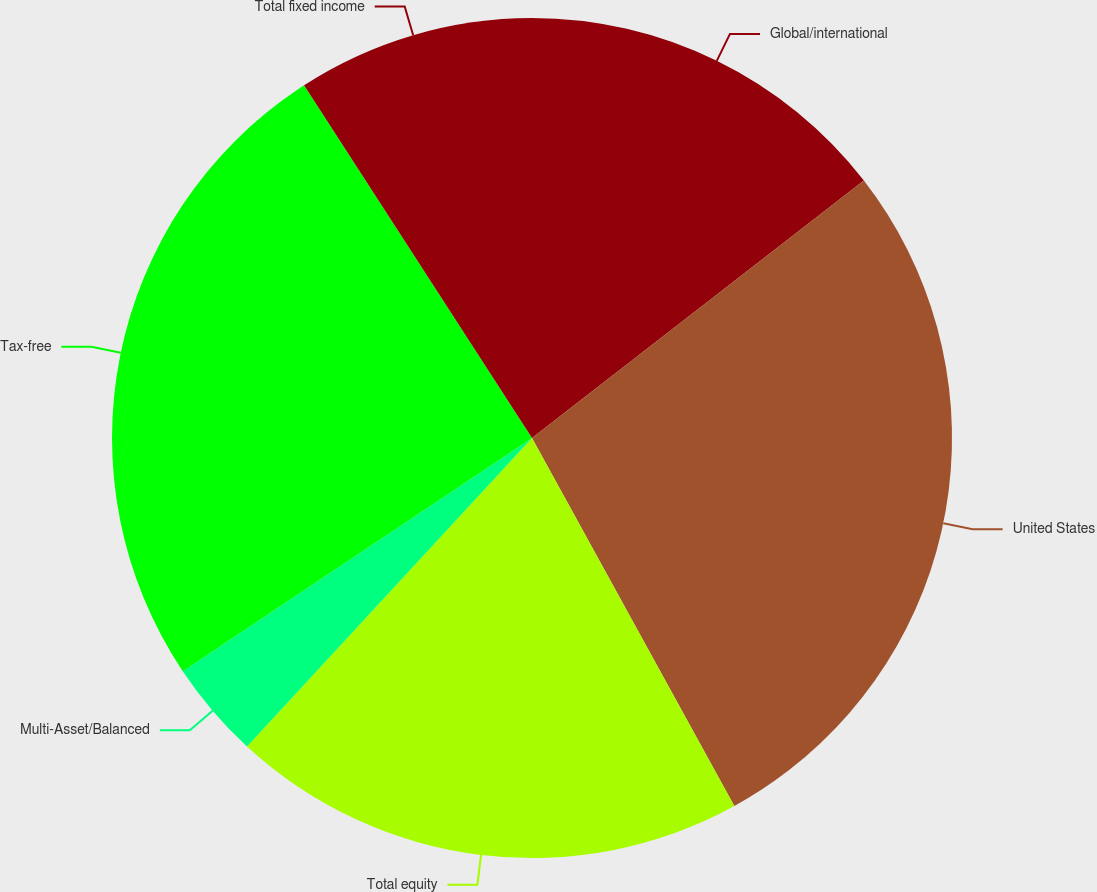Convert chart. <chart><loc_0><loc_0><loc_500><loc_500><pie_chart><fcel>Global/international<fcel>United States<fcel>Total equity<fcel>Multi-Asset/Balanced<fcel>Tax-free<fcel>Total fixed income<nl><fcel>14.5%<fcel>27.5%<fcel>19.87%<fcel>3.76%<fcel>25.24%<fcel>9.13%<nl></chart> 